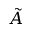Convert formula to latex. <formula><loc_0><loc_0><loc_500><loc_500>\tilde { A }</formula> 